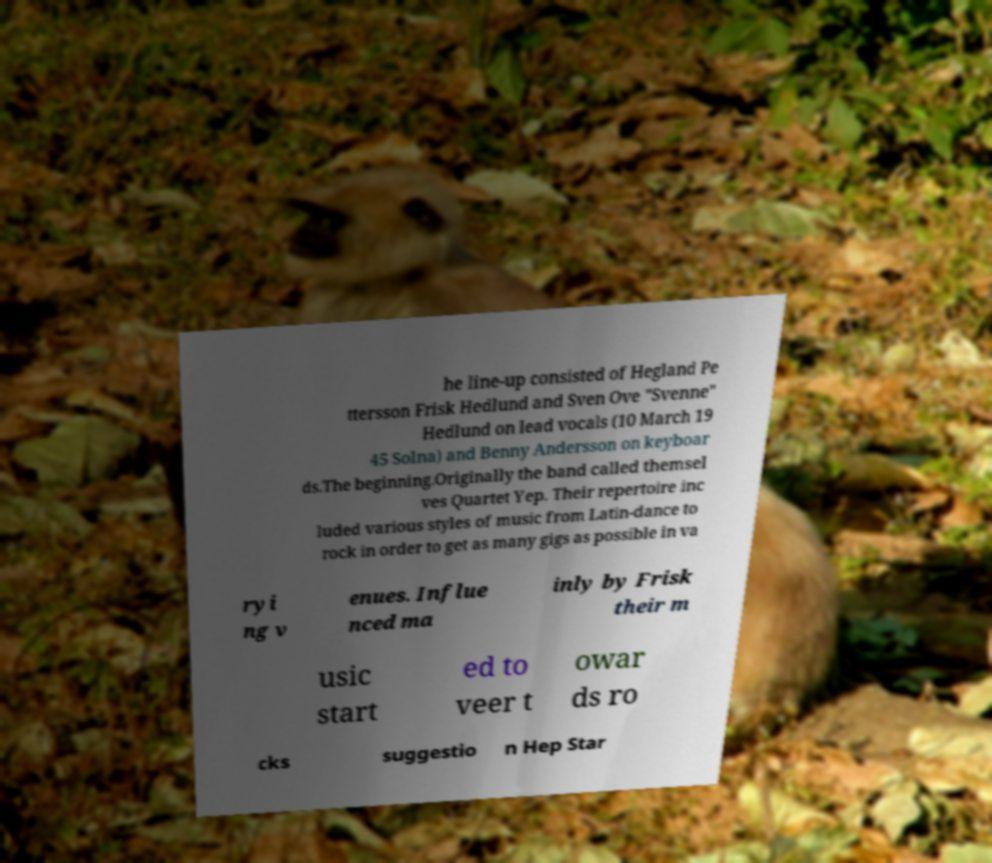Could you assist in decoding the text presented in this image and type it out clearly? he line-up consisted of Hegland Pe ttersson Frisk Hedlund and Sven Ove "Svenne" Hedlund on lead vocals (10 March 19 45 Solna) and Benny Andersson on keyboar ds.The beginning.Originally the band called themsel ves Quartet Yep. Their repertoire inc luded various styles of music from Latin-dance to rock in order to get as many gigs as possible in va ryi ng v enues. Influe nced ma inly by Frisk their m usic start ed to veer t owar ds ro cks suggestio n Hep Star 